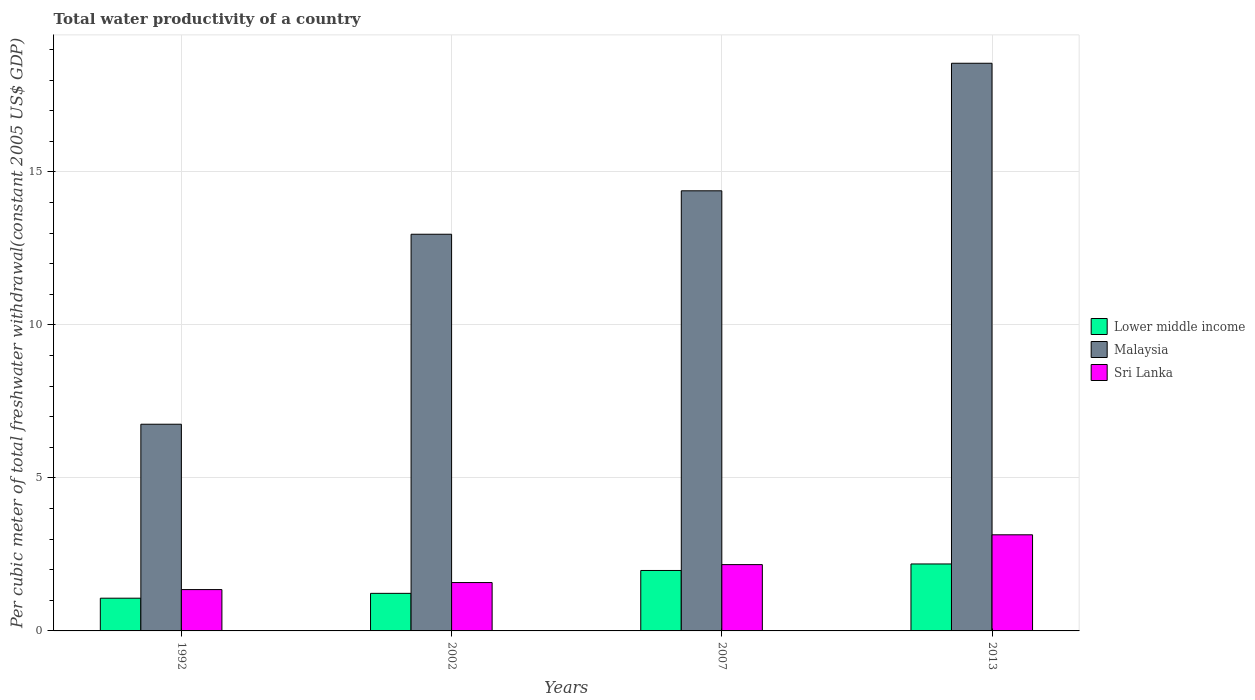How many different coloured bars are there?
Your response must be concise. 3. Are the number of bars on each tick of the X-axis equal?
Make the answer very short. Yes. How many bars are there on the 4th tick from the right?
Offer a very short reply. 3. What is the label of the 3rd group of bars from the left?
Offer a terse response. 2007. What is the total water productivity in Malaysia in 2007?
Your response must be concise. 14.38. Across all years, what is the maximum total water productivity in Malaysia?
Make the answer very short. 18.55. Across all years, what is the minimum total water productivity in Lower middle income?
Provide a succinct answer. 1.07. In which year was the total water productivity in Lower middle income minimum?
Offer a terse response. 1992. What is the total total water productivity in Lower middle income in the graph?
Provide a succinct answer. 6.46. What is the difference between the total water productivity in Sri Lanka in 1992 and that in 2013?
Offer a very short reply. -1.79. What is the difference between the total water productivity in Sri Lanka in 2007 and the total water productivity in Malaysia in 2013?
Offer a terse response. -16.39. What is the average total water productivity in Sri Lanka per year?
Your answer should be compact. 2.06. In the year 2013, what is the difference between the total water productivity in Sri Lanka and total water productivity in Malaysia?
Offer a terse response. -15.41. In how many years, is the total water productivity in Lower middle income greater than 6 US$?
Your answer should be compact. 0. What is the ratio of the total water productivity in Malaysia in 1992 to that in 2007?
Keep it short and to the point. 0.47. What is the difference between the highest and the second highest total water productivity in Malaysia?
Offer a very short reply. 4.17. What is the difference between the highest and the lowest total water productivity in Sri Lanka?
Keep it short and to the point. 1.79. What does the 3rd bar from the left in 2013 represents?
Your answer should be very brief. Sri Lanka. What does the 1st bar from the right in 1992 represents?
Keep it short and to the point. Sri Lanka. How many bars are there?
Provide a succinct answer. 12. Are all the bars in the graph horizontal?
Your answer should be very brief. No. How many years are there in the graph?
Provide a short and direct response. 4. How many legend labels are there?
Offer a very short reply. 3. What is the title of the graph?
Your answer should be very brief. Total water productivity of a country. Does "Kyrgyz Republic" appear as one of the legend labels in the graph?
Keep it short and to the point. No. What is the label or title of the Y-axis?
Offer a terse response. Per cubic meter of total freshwater withdrawal(constant 2005 US$ GDP). What is the Per cubic meter of total freshwater withdrawal(constant 2005 US$ GDP) of Lower middle income in 1992?
Ensure brevity in your answer.  1.07. What is the Per cubic meter of total freshwater withdrawal(constant 2005 US$ GDP) of Malaysia in 1992?
Offer a terse response. 6.76. What is the Per cubic meter of total freshwater withdrawal(constant 2005 US$ GDP) in Sri Lanka in 1992?
Offer a terse response. 1.35. What is the Per cubic meter of total freshwater withdrawal(constant 2005 US$ GDP) in Lower middle income in 2002?
Keep it short and to the point. 1.23. What is the Per cubic meter of total freshwater withdrawal(constant 2005 US$ GDP) of Malaysia in 2002?
Provide a succinct answer. 12.96. What is the Per cubic meter of total freshwater withdrawal(constant 2005 US$ GDP) of Sri Lanka in 2002?
Provide a short and direct response. 1.58. What is the Per cubic meter of total freshwater withdrawal(constant 2005 US$ GDP) of Lower middle income in 2007?
Offer a very short reply. 1.98. What is the Per cubic meter of total freshwater withdrawal(constant 2005 US$ GDP) in Malaysia in 2007?
Give a very brief answer. 14.38. What is the Per cubic meter of total freshwater withdrawal(constant 2005 US$ GDP) in Sri Lanka in 2007?
Your answer should be compact. 2.17. What is the Per cubic meter of total freshwater withdrawal(constant 2005 US$ GDP) in Lower middle income in 2013?
Provide a short and direct response. 2.19. What is the Per cubic meter of total freshwater withdrawal(constant 2005 US$ GDP) in Malaysia in 2013?
Offer a very short reply. 18.55. What is the Per cubic meter of total freshwater withdrawal(constant 2005 US$ GDP) of Sri Lanka in 2013?
Your response must be concise. 3.14. Across all years, what is the maximum Per cubic meter of total freshwater withdrawal(constant 2005 US$ GDP) in Lower middle income?
Provide a short and direct response. 2.19. Across all years, what is the maximum Per cubic meter of total freshwater withdrawal(constant 2005 US$ GDP) of Malaysia?
Offer a terse response. 18.55. Across all years, what is the maximum Per cubic meter of total freshwater withdrawal(constant 2005 US$ GDP) of Sri Lanka?
Make the answer very short. 3.14. Across all years, what is the minimum Per cubic meter of total freshwater withdrawal(constant 2005 US$ GDP) of Lower middle income?
Your answer should be very brief. 1.07. Across all years, what is the minimum Per cubic meter of total freshwater withdrawal(constant 2005 US$ GDP) in Malaysia?
Your answer should be very brief. 6.76. Across all years, what is the minimum Per cubic meter of total freshwater withdrawal(constant 2005 US$ GDP) of Sri Lanka?
Your response must be concise. 1.35. What is the total Per cubic meter of total freshwater withdrawal(constant 2005 US$ GDP) of Lower middle income in the graph?
Your answer should be very brief. 6.46. What is the total Per cubic meter of total freshwater withdrawal(constant 2005 US$ GDP) of Malaysia in the graph?
Provide a short and direct response. 52.65. What is the total Per cubic meter of total freshwater withdrawal(constant 2005 US$ GDP) in Sri Lanka in the graph?
Offer a very short reply. 8.24. What is the difference between the Per cubic meter of total freshwater withdrawal(constant 2005 US$ GDP) of Lower middle income in 1992 and that in 2002?
Ensure brevity in your answer.  -0.16. What is the difference between the Per cubic meter of total freshwater withdrawal(constant 2005 US$ GDP) of Malaysia in 1992 and that in 2002?
Your answer should be very brief. -6.21. What is the difference between the Per cubic meter of total freshwater withdrawal(constant 2005 US$ GDP) in Sri Lanka in 1992 and that in 2002?
Ensure brevity in your answer.  -0.23. What is the difference between the Per cubic meter of total freshwater withdrawal(constant 2005 US$ GDP) in Lower middle income in 1992 and that in 2007?
Offer a very short reply. -0.91. What is the difference between the Per cubic meter of total freshwater withdrawal(constant 2005 US$ GDP) in Malaysia in 1992 and that in 2007?
Provide a succinct answer. -7.63. What is the difference between the Per cubic meter of total freshwater withdrawal(constant 2005 US$ GDP) in Sri Lanka in 1992 and that in 2007?
Your response must be concise. -0.82. What is the difference between the Per cubic meter of total freshwater withdrawal(constant 2005 US$ GDP) of Lower middle income in 1992 and that in 2013?
Ensure brevity in your answer.  -1.12. What is the difference between the Per cubic meter of total freshwater withdrawal(constant 2005 US$ GDP) of Malaysia in 1992 and that in 2013?
Make the answer very short. -11.8. What is the difference between the Per cubic meter of total freshwater withdrawal(constant 2005 US$ GDP) of Sri Lanka in 1992 and that in 2013?
Make the answer very short. -1.79. What is the difference between the Per cubic meter of total freshwater withdrawal(constant 2005 US$ GDP) of Lower middle income in 2002 and that in 2007?
Offer a terse response. -0.75. What is the difference between the Per cubic meter of total freshwater withdrawal(constant 2005 US$ GDP) of Malaysia in 2002 and that in 2007?
Your answer should be very brief. -1.42. What is the difference between the Per cubic meter of total freshwater withdrawal(constant 2005 US$ GDP) of Sri Lanka in 2002 and that in 2007?
Provide a succinct answer. -0.59. What is the difference between the Per cubic meter of total freshwater withdrawal(constant 2005 US$ GDP) in Lower middle income in 2002 and that in 2013?
Your answer should be compact. -0.96. What is the difference between the Per cubic meter of total freshwater withdrawal(constant 2005 US$ GDP) of Malaysia in 2002 and that in 2013?
Provide a succinct answer. -5.59. What is the difference between the Per cubic meter of total freshwater withdrawal(constant 2005 US$ GDP) in Sri Lanka in 2002 and that in 2013?
Your answer should be very brief. -1.56. What is the difference between the Per cubic meter of total freshwater withdrawal(constant 2005 US$ GDP) of Lower middle income in 2007 and that in 2013?
Ensure brevity in your answer.  -0.21. What is the difference between the Per cubic meter of total freshwater withdrawal(constant 2005 US$ GDP) of Malaysia in 2007 and that in 2013?
Offer a terse response. -4.17. What is the difference between the Per cubic meter of total freshwater withdrawal(constant 2005 US$ GDP) in Sri Lanka in 2007 and that in 2013?
Provide a succinct answer. -0.97. What is the difference between the Per cubic meter of total freshwater withdrawal(constant 2005 US$ GDP) in Lower middle income in 1992 and the Per cubic meter of total freshwater withdrawal(constant 2005 US$ GDP) in Malaysia in 2002?
Offer a terse response. -11.89. What is the difference between the Per cubic meter of total freshwater withdrawal(constant 2005 US$ GDP) in Lower middle income in 1992 and the Per cubic meter of total freshwater withdrawal(constant 2005 US$ GDP) in Sri Lanka in 2002?
Keep it short and to the point. -0.51. What is the difference between the Per cubic meter of total freshwater withdrawal(constant 2005 US$ GDP) in Malaysia in 1992 and the Per cubic meter of total freshwater withdrawal(constant 2005 US$ GDP) in Sri Lanka in 2002?
Ensure brevity in your answer.  5.17. What is the difference between the Per cubic meter of total freshwater withdrawal(constant 2005 US$ GDP) in Lower middle income in 1992 and the Per cubic meter of total freshwater withdrawal(constant 2005 US$ GDP) in Malaysia in 2007?
Ensure brevity in your answer.  -13.31. What is the difference between the Per cubic meter of total freshwater withdrawal(constant 2005 US$ GDP) in Lower middle income in 1992 and the Per cubic meter of total freshwater withdrawal(constant 2005 US$ GDP) in Sri Lanka in 2007?
Make the answer very short. -1.1. What is the difference between the Per cubic meter of total freshwater withdrawal(constant 2005 US$ GDP) of Malaysia in 1992 and the Per cubic meter of total freshwater withdrawal(constant 2005 US$ GDP) of Sri Lanka in 2007?
Your response must be concise. 4.59. What is the difference between the Per cubic meter of total freshwater withdrawal(constant 2005 US$ GDP) in Lower middle income in 1992 and the Per cubic meter of total freshwater withdrawal(constant 2005 US$ GDP) in Malaysia in 2013?
Provide a short and direct response. -17.48. What is the difference between the Per cubic meter of total freshwater withdrawal(constant 2005 US$ GDP) of Lower middle income in 1992 and the Per cubic meter of total freshwater withdrawal(constant 2005 US$ GDP) of Sri Lanka in 2013?
Make the answer very short. -2.07. What is the difference between the Per cubic meter of total freshwater withdrawal(constant 2005 US$ GDP) of Malaysia in 1992 and the Per cubic meter of total freshwater withdrawal(constant 2005 US$ GDP) of Sri Lanka in 2013?
Provide a short and direct response. 3.61. What is the difference between the Per cubic meter of total freshwater withdrawal(constant 2005 US$ GDP) of Lower middle income in 2002 and the Per cubic meter of total freshwater withdrawal(constant 2005 US$ GDP) of Malaysia in 2007?
Provide a succinct answer. -13.16. What is the difference between the Per cubic meter of total freshwater withdrawal(constant 2005 US$ GDP) of Lower middle income in 2002 and the Per cubic meter of total freshwater withdrawal(constant 2005 US$ GDP) of Sri Lanka in 2007?
Give a very brief answer. -0.94. What is the difference between the Per cubic meter of total freshwater withdrawal(constant 2005 US$ GDP) in Malaysia in 2002 and the Per cubic meter of total freshwater withdrawal(constant 2005 US$ GDP) in Sri Lanka in 2007?
Ensure brevity in your answer.  10.8. What is the difference between the Per cubic meter of total freshwater withdrawal(constant 2005 US$ GDP) in Lower middle income in 2002 and the Per cubic meter of total freshwater withdrawal(constant 2005 US$ GDP) in Malaysia in 2013?
Your answer should be compact. -17.32. What is the difference between the Per cubic meter of total freshwater withdrawal(constant 2005 US$ GDP) in Lower middle income in 2002 and the Per cubic meter of total freshwater withdrawal(constant 2005 US$ GDP) in Sri Lanka in 2013?
Your answer should be very brief. -1.91. What is the difference between the Per cubic meter of total freshwater withdrawal(constant 2005 US$ GDP) of Malaysia in 2002 and the Per cubic meter of total freshwater withdrawal(constant 2005 US$ GDP) of Sri Lanka in 2013?
Ensure brevity in your answer.  9.82. What is the difference between the Per cubic meter of total freshwater withdrawal(constant 2005 US$ GDP) in Lower middle income in 2007 and the Per cubic meter of total freshwater withdrawal(constant 2005 US$ GDP) in Malaysia in 2013?
Offer a very short reply. -16.58. What is the difference between the Per cubic meter of total freshwater withdrawal(constant 2005 US$ GDP) of Lower middle income in 2007 and the Per cubic meter of total freshwater withdrawal(constant 2005 US$ GDP) of Sri Lanka in 2013?
Ensure brevity in your answer.  -1.17. What is the difference between the Per cubic meter of total freshwater withdrawal(constant 2005 US$ GDP) in Malaysia in 2007 and the Per cubic meter of total freshwater withdrawal(constant 2005 US$ GDP) in Sri Lanka in 2013?
Provide a short and direct response. 11.24. What is the average Per cubic meter of total freshwater withdrawal(constant 2005 US$ GDP) of Lower middle income per year?
Offer a very short reply. 1.62. What is the average Per cubic meter of total freshwater withdrawal(constant 2005 US$ GDP) in Malaysia per year?
Your answer should be very brief. 13.16. What is the average Per cubic meter of total freshwater withdrawal(constant 2005 US$ GDP) of Sri Lanka per year?
Your response must be concise. 2.06. In the year 1992, what is the difference between the Per cubic meter of total freshwater withdrawal(constant 2005 US$ GDP) in Lower middle income and Per cubic meter of total freshwater withdrawal(constant 2005 US$ GDP) in Malaysia?
Provide a succinct answer. -5.69. In the year 1992, what is the difference between the Per cubic meter of total freshwater withdrawal(constant 2005 US$ GDP) of Lower middle income and Per cubic meter of total freshwater withdrawal(constant 2005 US$ GDP) of Sri Lanka?
Offer a very short reply. -0.28. In the year 1992, what is the difference between the Per cubic meter of total freshwater withdrawal(constant 2005 US$ GDP) of Malaysia and Per cubic meter of total freshwater withdrawal(constant 2005 US$ GDP) of Sri Lanka?
Your answer should be very brief. 5.4. In the year 2002, what is the difference between the Per cubic meter of total freshwater withdrawal(constant 2005 US$ GDP) of Lower middle income and Per cubic meter of total freshwater withdrawal(constant 2005 US$ GDP) of Malaysia?
Make the answer very short. -11.74. In the year 2002, what is the difference between the Per cubic meter of total freshwater withdrawal(constant 2005 US$ GDP) of Lower middle income and Per cubic meter of total freshwater withdrawal(constant 2005 US$ GDP) of Sri Lanka?
Ensure brevity in your answer.  -0.35. In the year 2002, what is the difference between the Per cubic meter of total freshwater withdrawal(constant 2005 US$ GDP) of Malaysia and Per cubic meter of total freshwater withdrawal(constant 2005 US$ GDP) of Sri Lanka?
Ensure brevity in your answer.  11.38. In the year 2007, what is the difference between the Per cubic meter of total freshwater withdrawal(constant 2005 US$ GDP) in Lower middle income and Per cubic meter of total freshwater withdrawal(constant 2005 US$ GDP) in Malaysia?
Provide a short and direct response. -12.41. In the year 2007, what is the difference between the Per cubic meter of total freshwater withdrawal(constant 2005 US$ GDP) in Lower middle income and Per cubic meter of total freshwater withdrawal(constant 2005 US$ GDP) in Sri Lanka?
Your answer should be very brief. -0.19. In the year 2007, what is the difference between the Per cubic meter of total freshwater withdrawal(constant 2005 US$ GDP) of Malaysia and Per cubic meter of total freshwater withdrawal(constant 2005 US$ GDP) of Sri Lanka?
Give a very brief answer. 12.22. In the year 2013, what is the difference between the Per cubic meter of total freshwater withdrawal(constant 2005 US$ GDP) of Lower middle income and Per cubic meter of total freshwater withdrawal(constant 2005 US$ GDP) of Malaysia?
Offer a very short reply. -16.36. In the year 2013, what is the difference between the Per cubic meter of total freshwater withdrawal(constant 2005 US$ GDP) in Lower middle income and Per cubic meter of total freshwater withdrawal(constant 2005 US$ GDP) in Sri Lanka?
Your answer should be very brief. -0.95. In the year 2013, what is the difference between the Per cubic meter of total freshwater withdrawal(constant 2005 US$ GDP) in Malaysia and Per cubic meter of total freshwater withdrawal(constant 2005 US$ GDP) in Sri Lanka?
Your answer should be very brief. 15.41. What is the ratio of the Per cubic meter of total freshwater withdrawal(constant 2005 US$ GDP) in Lower middle income in 1992 to that in 2002?
Make the answer very short. 0.87. What is the ratio of the Per cubic meter of total freshwater withdrawal(constant 2005 US$ GDP) in Malaysia in 1992 to that in 2002?
Your response must be concise. 0.52. What is the ratio of the Per cubic meter of total freshwater withdrawal(constant 2005 US$ GDP) in Sri Lanka in 1992 to that in 2002?
Offer a terse response. 0.85. What is the ratio of the Per cubic meter of total freshwater withdrawal(constant 2005 US$ GDP) of Lower middle income in 1992 to that in 2007?
Offer a terse response. 0.54. What is the ratio of the Per cubic meter of total freshwater withdrawal(constant 2005 US$ GDP) in Malaysia in 1992 to that in 2007?
Keep it short and to the point. 0.47. What is the ratio of the Per cubic meter of total freshwater withdrawal(constant 2005 US$ GDP) of Sri Lanka in 1992 to that in 2007?
Provide a short and direct response. 0.62. What is the ratio of the Per cubic meter of total freshwater withdrawal(constant 2005 US$ GDP) of Lower middle income in 1992 to that in 2013?
Keep it short and to the point. 0.49. What is the ratio of the Per cubic meter of total freshwater withdrawal(constant 2005 US$ GDP) of Malaysia in 1992 to that in 2013?
Make the answer very short. 0.36. What is the ratio of the Per cubic meter of total freshwater withdrawal(constant 2005 US$ GDP) in Sri Lanka in 1992 to that in 2013?
Your response must be concise. 0.43. What is the ratio of the Per cubic meter of total freshwater withdrawal(constant 2005 US$ GDP) in Lower middle income in 2002 to that in 2007?
Your answer should be very brief. 0.62. What is the ratio of the Per cubic meter of total freshwater withdrawal(constant 2005 US$ GDP) in Malaysia in 2002 to that in 2007?
Ensure brevity in your answer.  0.9. What is the ratio of the Per cubic meter of total freshwater withdrawal(constant 2005 US$ GDP) in Sri Lanka in 2002 to that in 2007?
Your response must be concise. 0.73. What is the ratio of the Per cubic meter of total freshwater withdrawal(constant 2005 US$ GDP) in Lower middle income in 2002 to that in 2013?
Ensure brevity in your answer.  0.56. What is the ratio of the Per cubic meter of total freshwater withdrawal(constant 2005 US$ GDP) in Malaysia in 2002 to that in 2013?
Provide a short and direct response. 0.7. What is the ratio of the Per cubic meter of total freshwater withdrawal(constant 2005 US$ GDP) of Sri Lanka in 2002 to that in 2013?
Provide a short and direct response. 0.5. What is the ratio of the Per cubic meter of total freshwater withdrawal(constant 2005 US$ GDP) of Lower middle income in 2007 to that in 2013?
Provide a succinct answer. 0.9. What is the ratio of the Per cubic meter of total freshwater withdrawal(constant 2005 US$ GDP) in Malaysia in 2007 to that in 2013?
Offer a terse response. 0.78. What is the ratio of the Per cubic meter of total freshwater withdrawal(constant 2005 US$ GDP) of Sri Lanka in 2007 to that in 2013?
Make the answer very short. 0.69. What is the difference between the highest and the second highest Per cubic meter of total freshwater withdrawal(constant 2005 US$ GDP) of Lower middle income?
Keep it short and to the point. 0.21. What is the difference between the highest and the second highest Per cubic meter of total freshwater withdrawal(constant 2005 US$ GDP) of Malaysia?
Give a very brief answer. 4.17. What is the difference between the highest and the second highest Per cubic meter of total freshwater withdrawal(constant 2005 US$ GDP) of Sri Lanka?
Your answer should be very brief. 0.97. What is the difference between the highest and the lowest Per cubic meter of total freshwater withdrawal(constant 2005 US$ GDP) in Lower middle income?
Provide a short and direct response. 1.12. What is the difference between the highest and the lowest Per cubic meter of total freshwater withdrawal(constant 2005 US$ GDP) of Malaysia?
Offer a very short reply. 11.8. What is the difference between the highest and the lowest Per cubic meter of total freshwater withdrawal(constant 2005 US$ GDP) of Sri Lanka?
Make the answer very short. 1.79. 